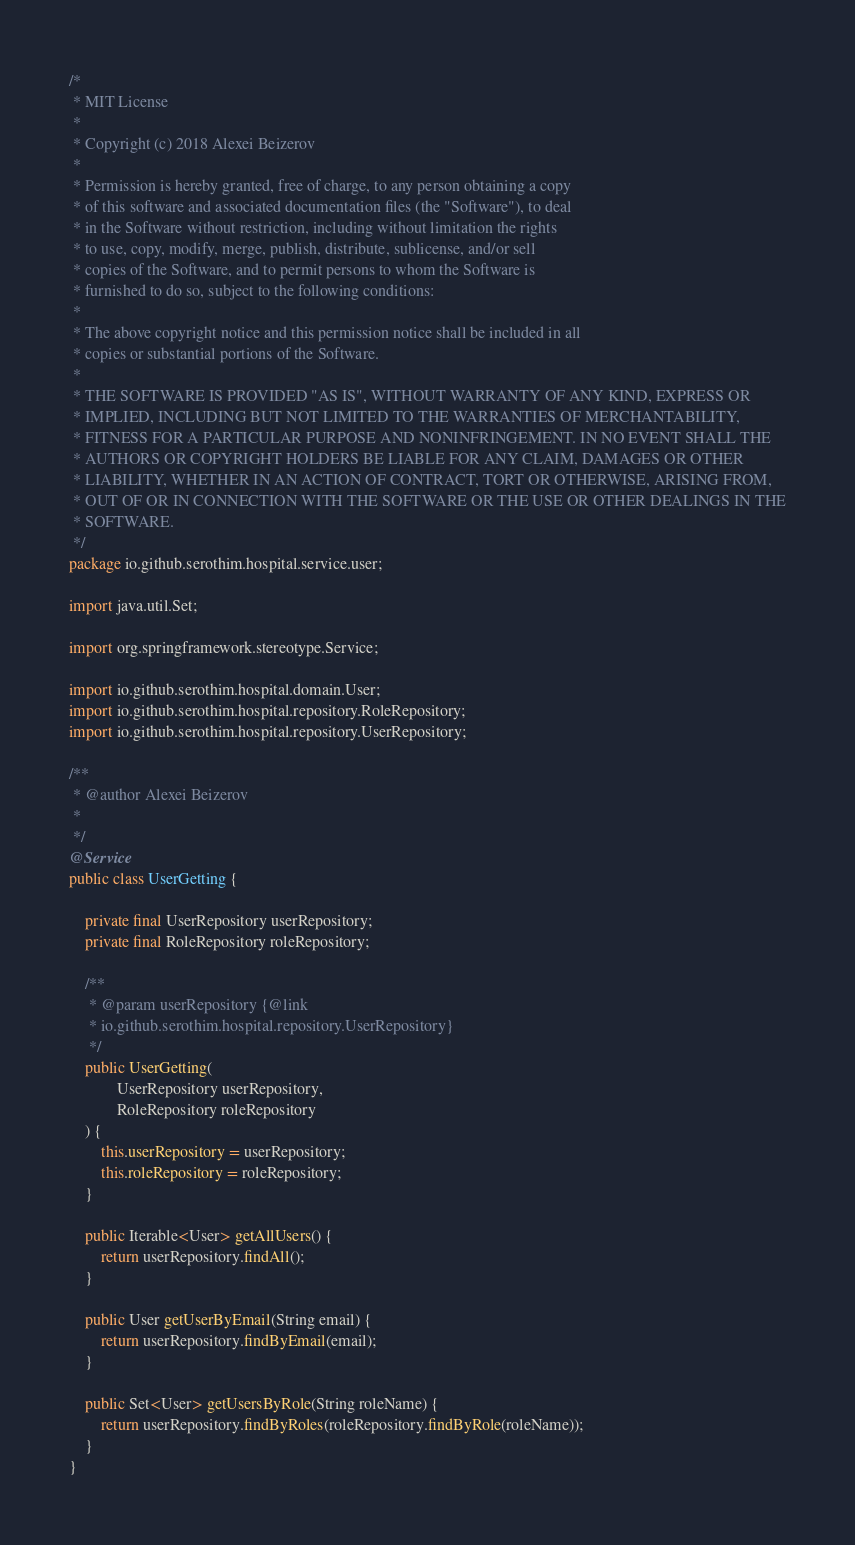Convert code to text. <code><loc_0><loc_0><loc_500><loc_500><_Java_>/*
 * MIT License
 * 
 * Copyright (c) 2018 Alexei Beizerov
 * 
 * Permission is hereby granted, free of charge, to any person obtaining a copy
 * of this software and associated documentation files (the "Software"), to deal
 * in the Software without restriction, including without limitation the rights
 * to use, copy, modify, merge, publish, distribute, sublicense, and/or sell
 * copies of the Software, and to permit persons to whom the Software is
 * furnished to do so, subject to the following conditions:
 * 
 * The above copyright notice and this permission notice shall be included in all
 * copies or substantial portions of the Software.
 * 
 * THE SOFTWARE IS PROVIDED "AS IS", WITHOUT WARRANTY OF ANY KIND, EXPRESS OR
 * IMPLIED, INCLUDING BUT NOT LIMITED TO THE WARRANTIES OF MERCHANTABILITY,
 * FITNESS FOR A PARTICULAR PURPOSE AND NONINFRINGEMENT. IN NO EVENT SHALL THE
 * AUTHORS OR COPYRIGHT HOLDERS BE LIABLE FOR ANY CLAIM, DAMAGES OR OTHER
 * LIABILITY, WHETHER IN AN ACTION OF CONTRACT, TORT OR OTHERWISE, ARISING FROM,
 * OUT OF OR IN CONNECTION WITH THE SOFTWARE OR THE USE OR OTHER DEALINGS IN THE
 * SOFTWARE.
 */
package io.github.serothim.hospital.service.user;

import java.util.Set;

import org.springframework.stereotype.Service;

import io.github.serothim.hospital.domain.User;
import io.github.serothim.hospital.repository.RoleRepository;
import io.github.serothim.hospital.repository.UserRepository;

/**
 * @author Alexei Beizerov
 *
 */
@Service
public class UserGetting {

	private final UserRepository userRepository;
	private final RoleRepository roleRepository;

	/**
	 * @param userRepository {@link 
	 * io.github.serothim.hospital.repository.UserRepository}
	 */
	public UserGetting(
			UserRepository userRepository, 
			RoleRepository roleRepository
	) {
		this.userRepository = userRepository;
		this.roleRepository = roleRepository;
	}

	public Iterable<User> getAllUsers() {
		return userRepository.findAll();
	}
	
	public User getUserByEmail(String email) {
		return userRepository.findByEmail(email);
	}
	
	public Set<User> getUsersByRole(String roleName) {
		return userRepository.findByRoles(roleRepository.findByRole(roleName));
	}
}</code> 